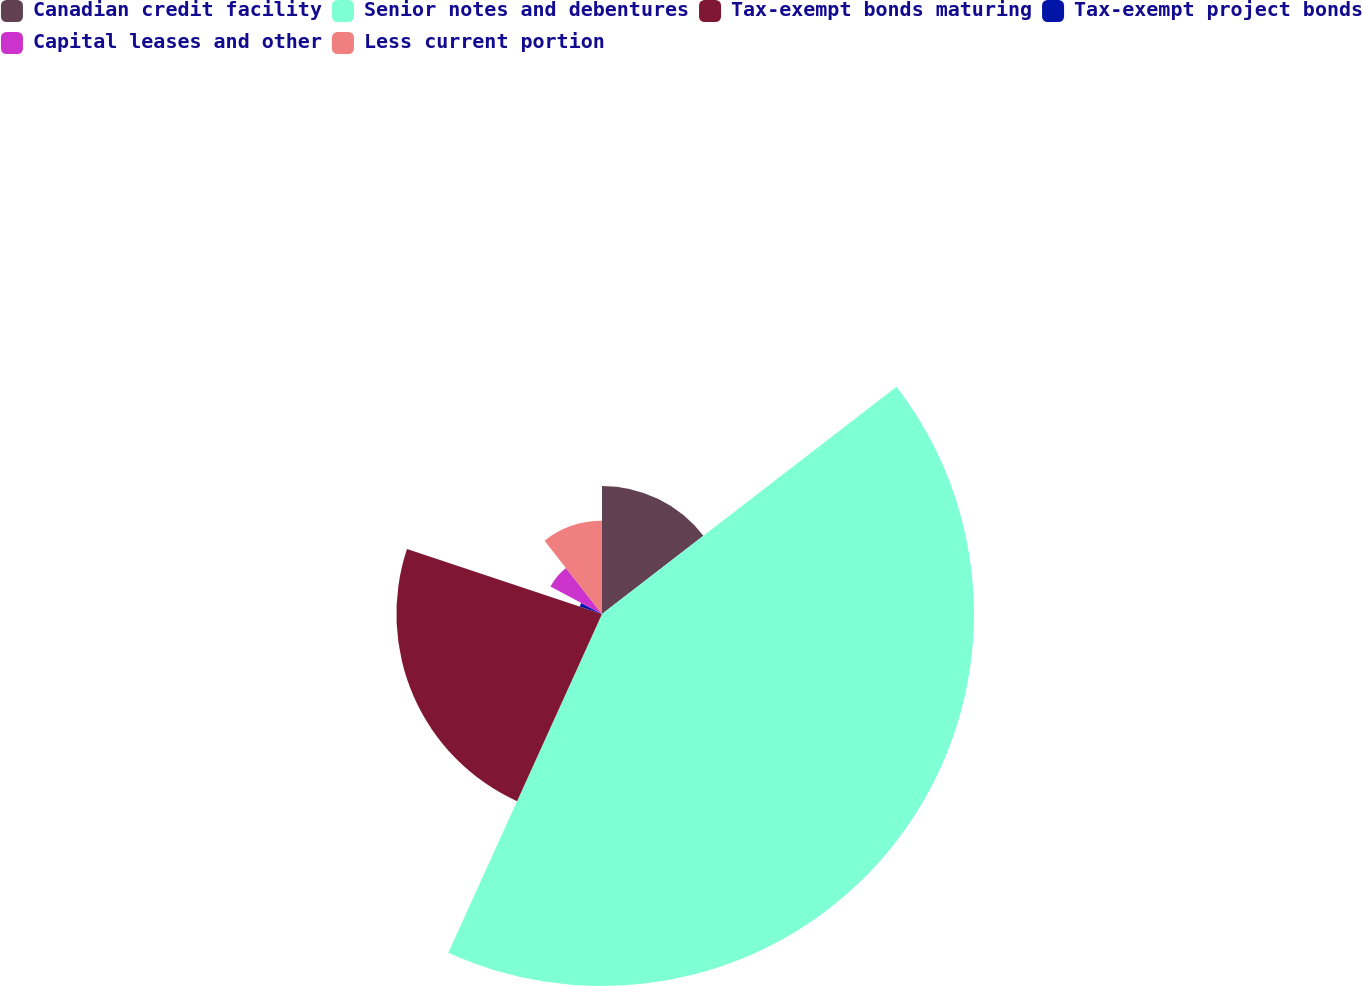Convert chart to OTSL. <chart><loc_0><loc_0><loc_500><loc_500><pie_chart><fcel>Canadian credit facility<fcel>Senior notes and debentures<fcel>Tax-exempt bonds maturing<fcel>Tax-exempt project bonds<fcel>Capital leases and other<fcel>Less current portion<nl><fcel>14.54%<fcel>42.24%<fcel>23.34%<fcel>2.67%<fcel>6.63%<fcel>10.58%<nl></chart> 